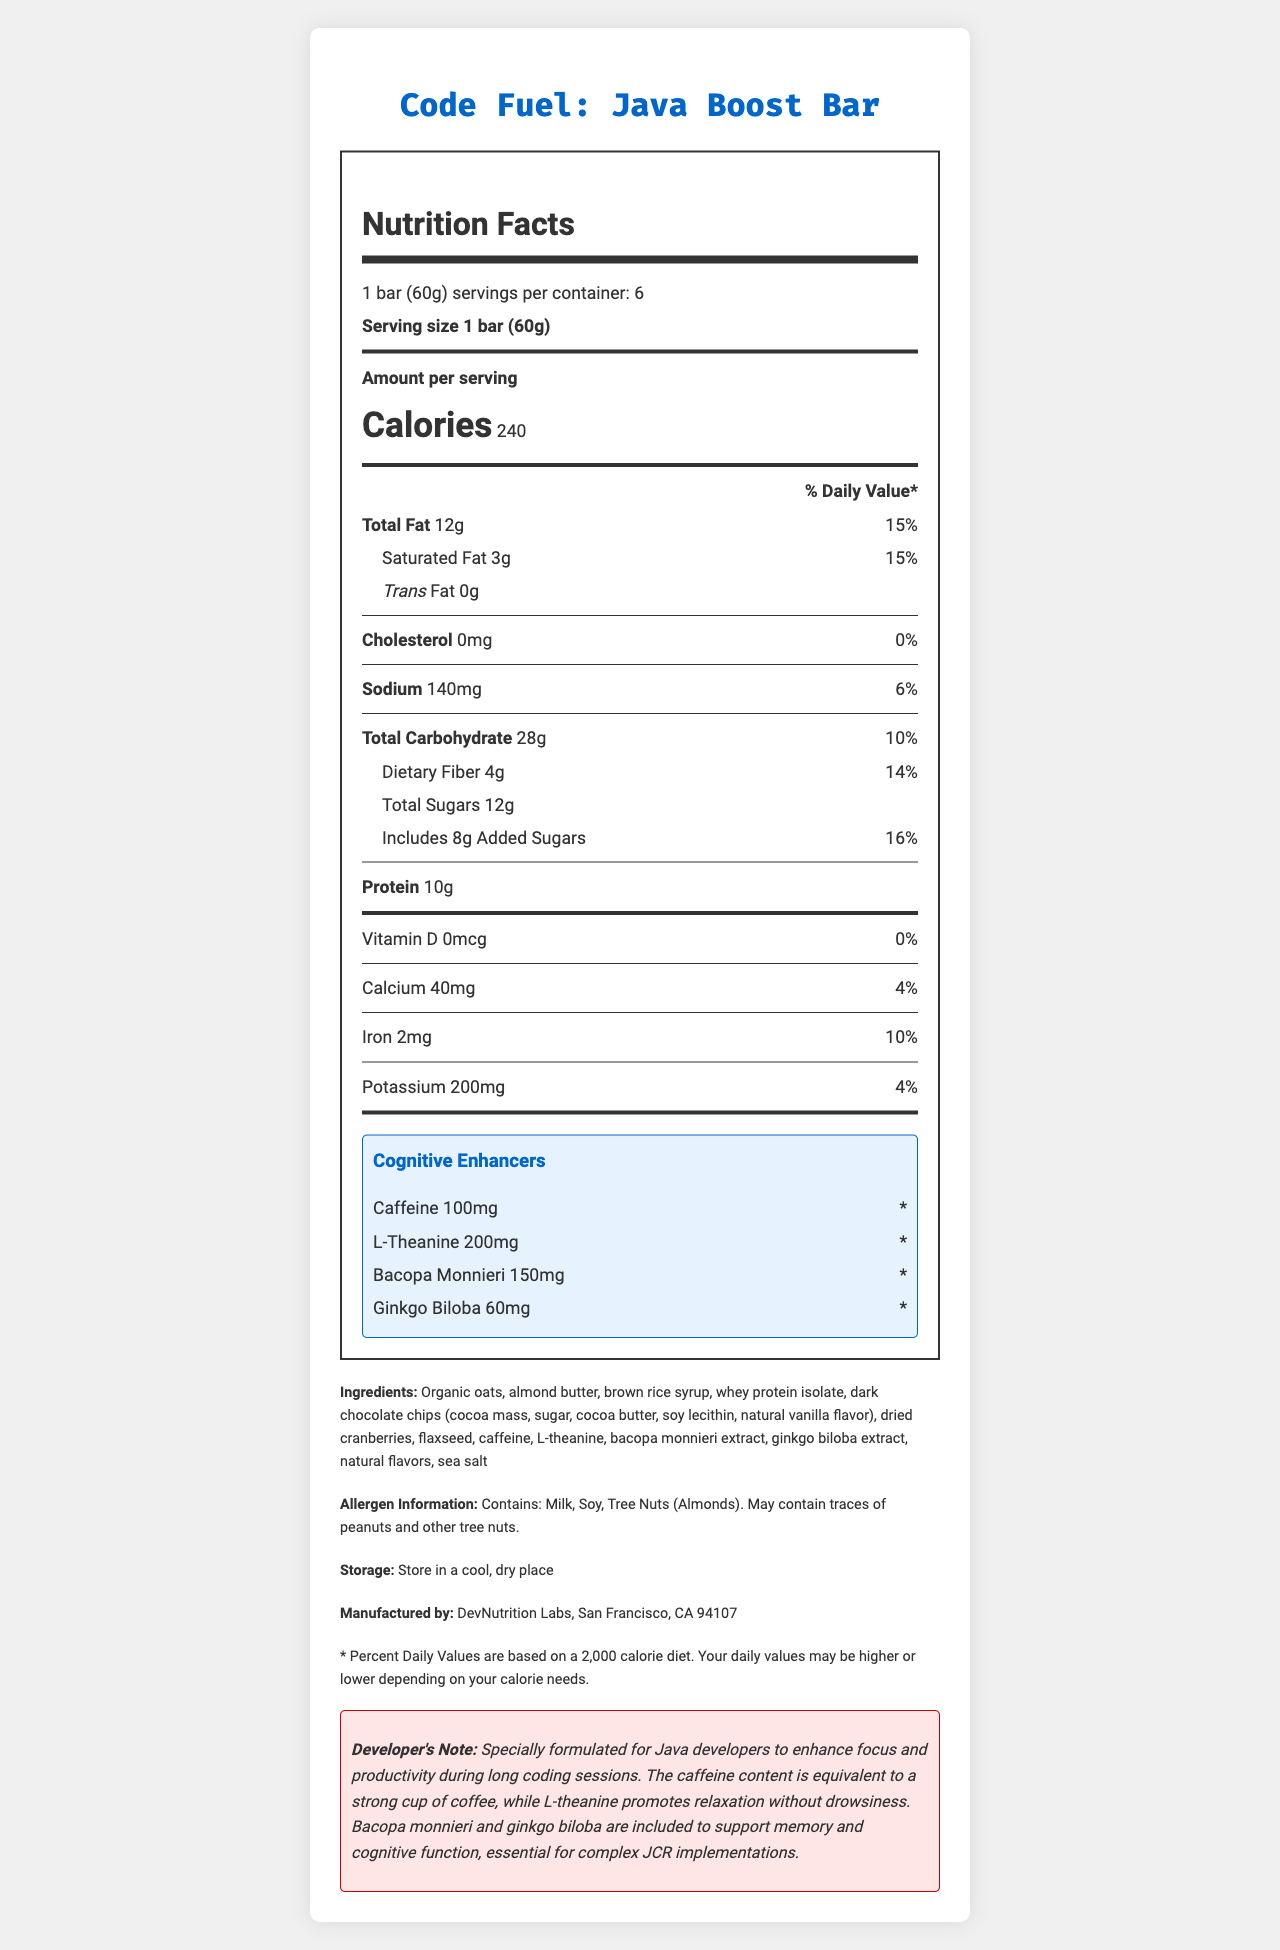what is the serving size of the "Code Fuel: Java Boost Bar"? The document states the serving size as "1 bar (60g)".
Answer: 1 bar (60g) how many calories are there per serving? The document states that each serving contains 240 calories.
Answer: 240 what percentage of the daily value of total fat does "Code Fuel: Java Boost Bar" provide? The document lists the total fat as "12g" with a daily value percentage of "15%".
Answer: 15% how many grams of protein are in one bar? The document lists "Protein 10g" under the nutritional information section.
Answer: 10g what is the amount of added sugars in one serving of "Code Fuel: Java Boost Bar"? The document mentions "Includes 8g Added Sugars" under the total sugars section.
Answer: 8g which of the following cognitive enhancers is present in the highest amount in the bar? A. Caffeine B. L-theanine C. Bacopa Monnieri D. Ginkgo Biloba The document states that L-theanine has an amount of 200mg, which is the highest compared to the others.
Answer: B. L-theanine which ingredient is NOT listed as an allergen in the "Code Fuel: Java Boost Bar"? A. Milk B. Soy C. Almonds D. Peanuts The document states that the bar contains milk, soy, and tree nuts (almonds) but mentions peanuts only as a possible trace.
Answer: D. Peanuts does the "Code Fuel: Java Boost Bar" contain trans fat? The document specifies "Trans Fat 0g".
Answer: No does the "Code Fuel: Java Boost Bar" contain any cholesterol? The document specifies "Cholesterol 0mg".
Answer: No summarize the main idea of the "Code Fuel: Java Boost Bar" nutrition facts label The document aims to inform the consumer about the nutritional content and the cognitive enhancers added to the snack bar, indicating its suitability for Java developers with cognitive enhancing ingredients.
Answer: The "Code Fuel: Java Boost Bar" nutrition facts label provides detailed nutritional information including serving size, calories, macronutrients, vitamins, and minerals per serving. It also highlights the amounts of specific cognitive enhancers in the bar and mentions ingredient and allergen information. what is the manufacturer's location? The document states that the manufacturer is "DevNutrition Labs, San Francisco, CA 94107".
Answer: San Francisco, CA 94107 how much Bacopa Monnieri is in the "Code Fuel: Java Boost Bar"? The document lists "Bacopa Monnieri" as 150mg under the cognitive enhancers section.
Answer: 150mg what is the total carbohydrate content in one serving? The document mentions "Total Carbohydrate 28g" under the nutritional information section.
Answer: 28g which of the following is a key feature mentioned for the "Code Fuel: Java Boost Bar"? A. Gluten-free B. Supports memory C. High in Vitamin C The developer's note mentions that Bacopa Monnieri and ginkgo biloba are included to support memory and cognitive function.
Answer: B. Supports memory what is the storage recommendation for the "Code Fuel: Java Boost Bar"? The document provides this storage recommendation under the storage section.
Answer: Store in a cool, dry place are the daily values percentages for cognitive enhancers provided? The document states that the daily values for cognitive enhancers are marked with an asterisk (*), indicating that they are not established.
Answer: No Based on the nutritional facts, would the "Code Fuel: Java Boost Bar" be suitable for someone on a low-sodium diet? The document lists 140mg sodium as 6% of the daily value, but without additional context on what constitutes a low-sodium diet or individual dietary needs, it cannot be determined from this information alone.
Answer: Cannot be determined 